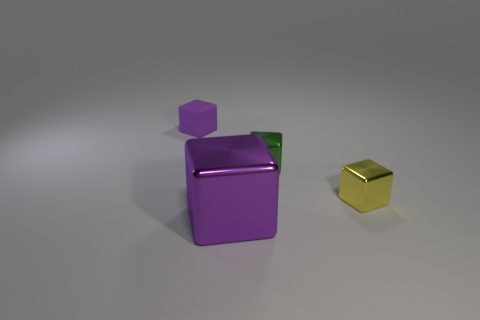Subtract all green cubes. How many cubes are left? 3 Subtract all purple cubes. How many cubes are left? 2 Subtract 1 cubes. How many cubes are left? 3 Add 4 green metallic objects. How many green metallic objects exist? 5 Add 1 yellow metallic blocks. How many objects exist? 5 Subtract 0 purple balls. How many objects are left? 4 Subtract all cyan blocks. Subtract all yellow cylinders. How many blocks are left? 4 Subtract all gray spheres. How many green cubes are left? 1 Subtract all big blocks. Subtract all yellow blocks. How many objects are left? 2 Add 4 green shiny objects. How many green shiny objects are left? 5 